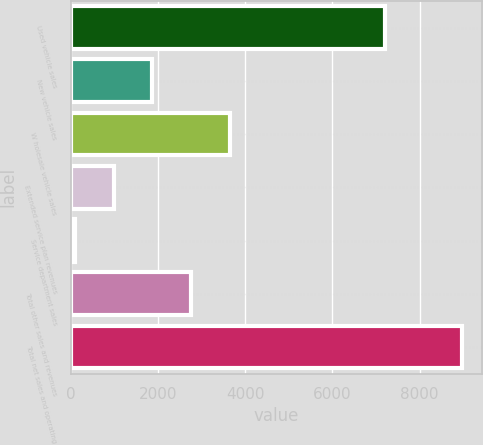<chart> <loc_0><loc_0><loc_500><loc_500><bar_chart><fcel>Used vehicle sales<fcel>New vehicle sales<fcel>W holesale vehicle sales<fcel>Extended service plan revenues<fcel>Service department sales<fcel>Total other sales and revenues<fcel>Total net sales and operating<nl><fcel>7210<fcel>1875.6<fcel>3650.6<fcel>988.1<fcel>100.6<fcel>2763.1<fcel>8975.6<nl></chart> 